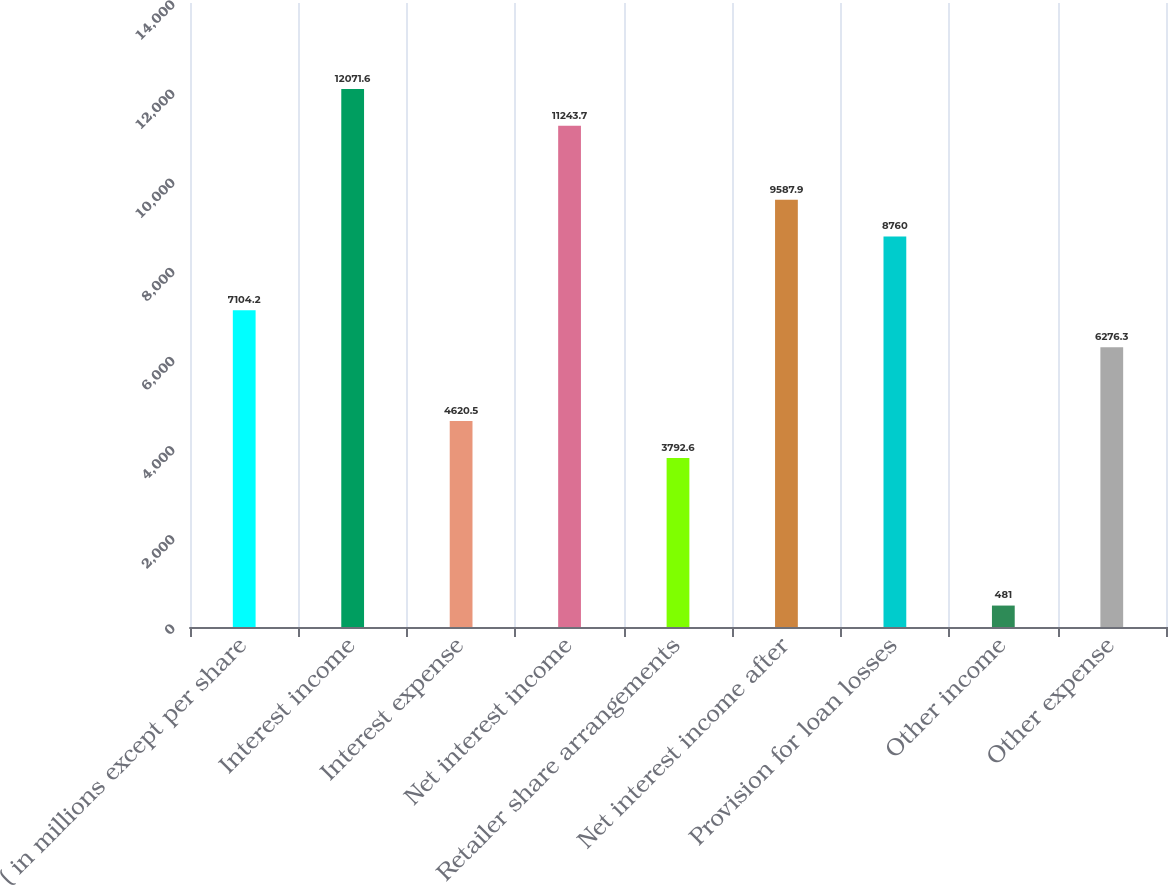Convert chart to OTSL. <chart><loc_0><loc_0><loc_500><loc_500><bar_chart><fcel>( in millions except per share<fcel>Interest income<fcel>Interest expense<fcel>Net interest income<fcel>Retailer share arrangements<fcel>Net interest income after<fcel>Provision for loan losses<fcel>Other income<fcel>Other expense<nl><fcel>7104.2<fcel>12071.6<fcel>4620.5<fcel>11243.7<fcel>3792.6<fcel>9587.9<fcel>8760<fcel>481<fcel>6276.3<nl></chart> 